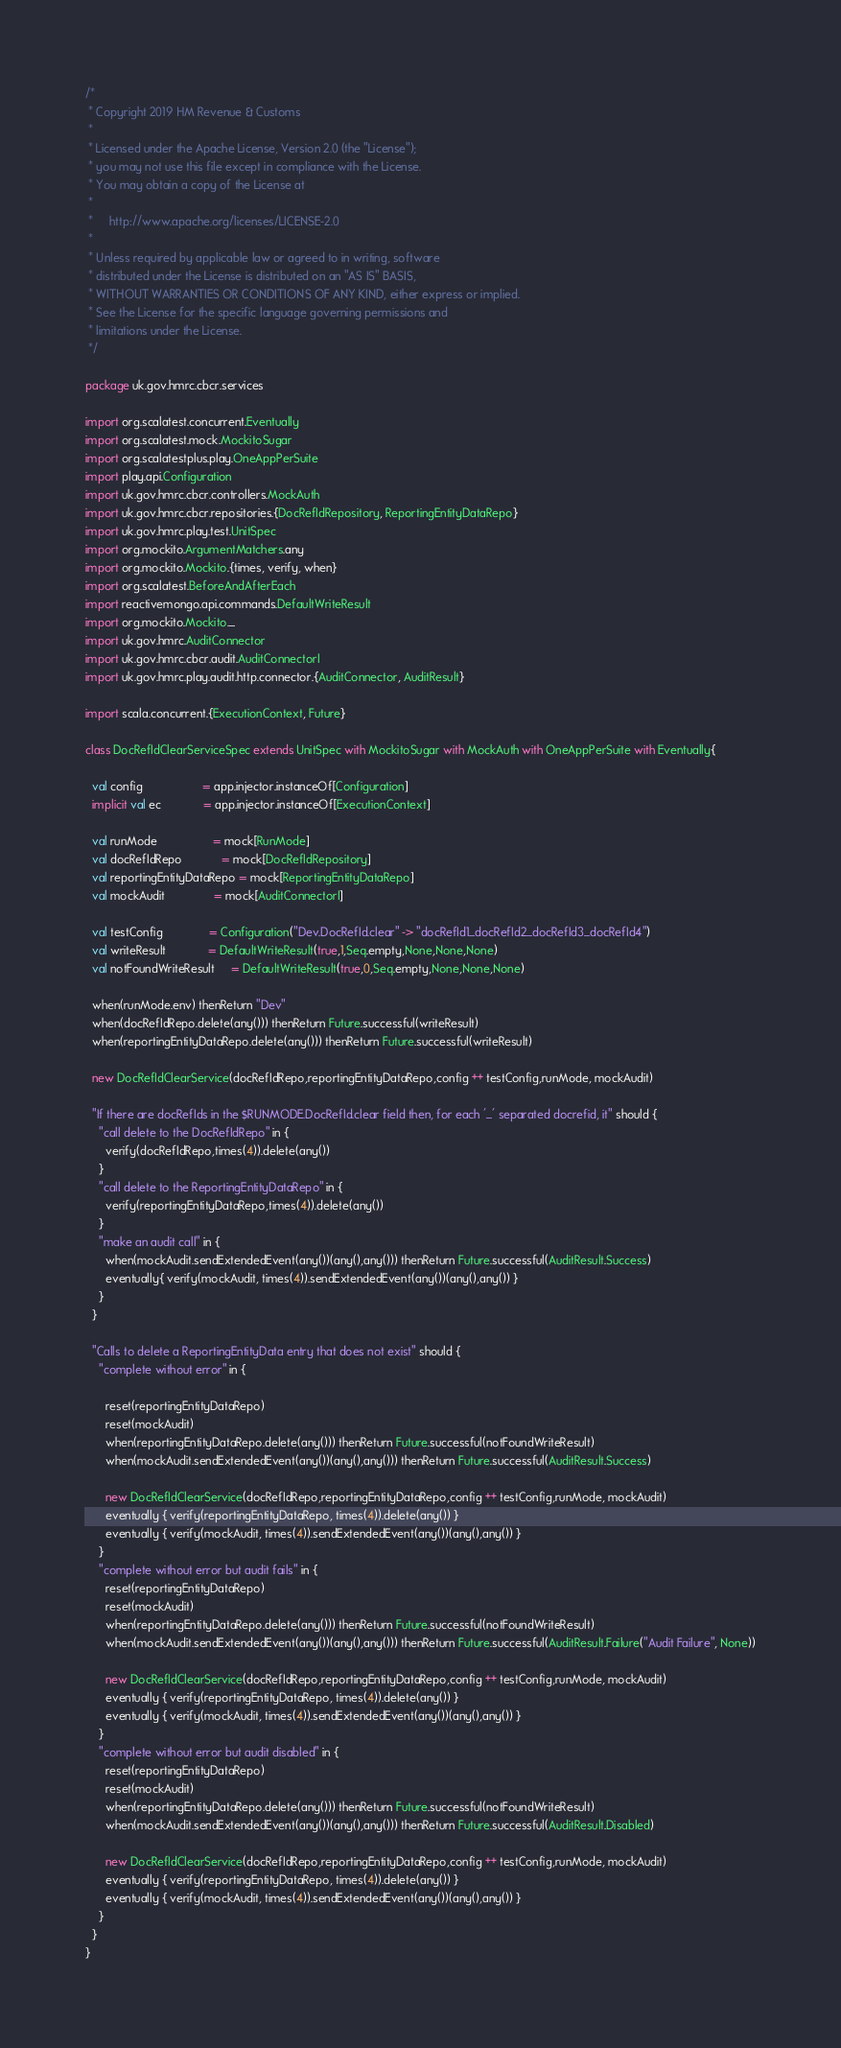<code> <loc_0><loc_0><loc_500><loc_500><_Scala_>/*
 * Copyright 2019 HM Revenue & Customs
 *
 * Licensed under the Apache License, Version 2.0 (the "License");
 * you may not use this file except in compliance with the License.
 * You may obtain a copy of the License at
 *
 *     http://www.apache.org/licenses/LICENSE-2.0
 *
 * Unless required by applicable law or agreed to in writing, software
 * distributed under the License is distributed on an "AS IS" BASIS,
 * WITHOUT WARRANTIES OR CONDITIONS OF ANY KIND, either express or implied.
 * See the License for the specific language governing permissions and
 * limitations under the License.
 */

package uk.gov.hmrc.cbcr.services

import org.scalatest.concurrent.Eventually
import org.scalatest.mock.MockitoSugar
import org.scalatestplus.play.OneAppPerSuite
import play.api.Configuration
import uk.gov.hmrc.cbcr.controllers.MockAuth
import uk.gov.hmrc.cbcr.repositories.{DocRefIdRepository, ReportingEntityDataRepo}
import uk.gov.hmrc.play.test.UnitSpec
import org.mockito.ArgumentMatchers.any
import org.mockito.Mockito.{times, verify, when}
import org.scalatest.BeforeAndAfterEach
import reactivemongo.api.commands.DefaultWriteResult
import org.mockito.Mockito._
import uk.gov.hmrc.AuditConnector
import uk.gov.hmrc.cbcr.audit.AuditConnectorI
import uk.gov.hmrc.play.audit.http.connector.{AuditConnector, AuditResult}

import scala.concurrent.{ExecutionContext, Future}

class DocRefIdClearServiceSpec extends UnitSpec with MockitoSugar with MockAuth with OneAppPerSuite with Eventually{

  val config                  = app.injector.instanceOf[Configuration]
  implicit val ec             = app.injector.instanceOf[ExecutionContext]

  val runMode                 = mock[RunMode]
  val docRefIdRepo            = mock[DocRefIdRepository]
  val reportingEntityDataRepo = mock[ReportingEntityDataRepo]
  val mockAudit               = mock[AuditConnectorI]

  val testConfig              = Configuration("Dev.DocRefId.clear" -> "docRefId1_docRefId2_docRefId3_docRefId4")
  val writeResult             = DefaultWriteResult(true,1,Seq.empty,None,None,None)
  val notFoundWriteResult     = DefaultWriteResult(true,0,Seq.empty,None,None,None)

  when(runMode.env) thenReturn "Dev"
  when(docRefIdRepo.delete(any())) thenReturn Future.successful(writeResult)
  when(reportingEntityDataRepo.delete(any())) thenReturn Future.successful(writeResult)

  new DocRefIdClearService(docRefIdRepo,reportingEntityDataRepo,config ++ testConfig,runMode, mockAudit)

  "If there are docRefIds in the $RUNMODE.DocRefId.clear field then, for each '_' separated docrefid, it" should {
    "call delete to the DocRefIdRepo" in {
      verify(docRefIdRepo,times(4)).delete(any())
    }
    "call delete to the ReportingEntityDataRepo" in {
      verify(reportingEntityDataRepo,times(4)).delete(any())
    }
    "make an audit call" in {
      when(mockAudit.sendExtendedEvent(any())(any(),any())) thenReturn Future.successful(AuditResult.Success)
      eventually{ verify(mockAudit, times(4)).sendExtendedEvent(any())(any(),any()) }
    }
  }

  "Calls to delete a ReportingEntityData entry that does not exist" should {
    "complete without error" in {

      reset(reportingEntityDataRepo)
      reset(mockAudit)
      when(reportingEntityDataRepo.delete(any())) thenReturn Future.successful(notFoundWriteResult)
      when(mockAudit.sendExtendedEvent(any())(any(),any())) thenReturn Future.successful(AuditResult.Success)

      new DocRefIdClearService(docRefIdRepo,reportingEntityDataRepo,config ++ testConfig,runMode, mockAudit)
      eventually { verify(reportingEntityDataRepo, times(4)).delete(any()) }
      eventually { verify(mockAudit, times(4)).sendExtendedEvent(any())(any(),any()) }
    }
    "complete without error but audit fails" in {
      reset(reportingEntityDataRepo)
      reset(mockAudit)
      when(reportingEntityDataRepo.delete(any())) thenReturn Future.successful(notFoundWriteResult)
      when(mockAudit.sendExtendedEvent(any())(any(),any())) thenReturn Future.successful(AuditResult.Failure("Audit Failure", None))

      new DocRefIdClearService(docRefIdRepo,reportingEntityDataRepo,config ++ testConfig,runMode, mockAudit)
      eventually { verify(reportingEntityDataRepo, times(4)).delete(any()) }
      eventually { verify(mockAudit, times(4)).sendExtendedEvent(any())(any(),any()) }
    }
    "complete without error but audit disabled" in {
      reset(reportingEntityDataRepo)
      reset(mockAudit)
      when(reportingEntityDataRepo.delete(any())) thenReturn Future.successful(notFoundWriteResult)
      when(mockAudit.sendExtendedEvent(any())(any(),any())) thenReturn Future.successful(AuditResult.Disabled)

      new DocRefIdClearService(docRefIdRepo,reportingEntityDataRepo,config ++ testConfig,runMode, mockAudit)
      eventually { verify(reportingEntityDataRepo, times(4)).delete(any()) }
      eventually { verify(mockAudit, times(4)).sendExtendedEvent(any())(any(),any()) }
    }
  }
}
</code> 